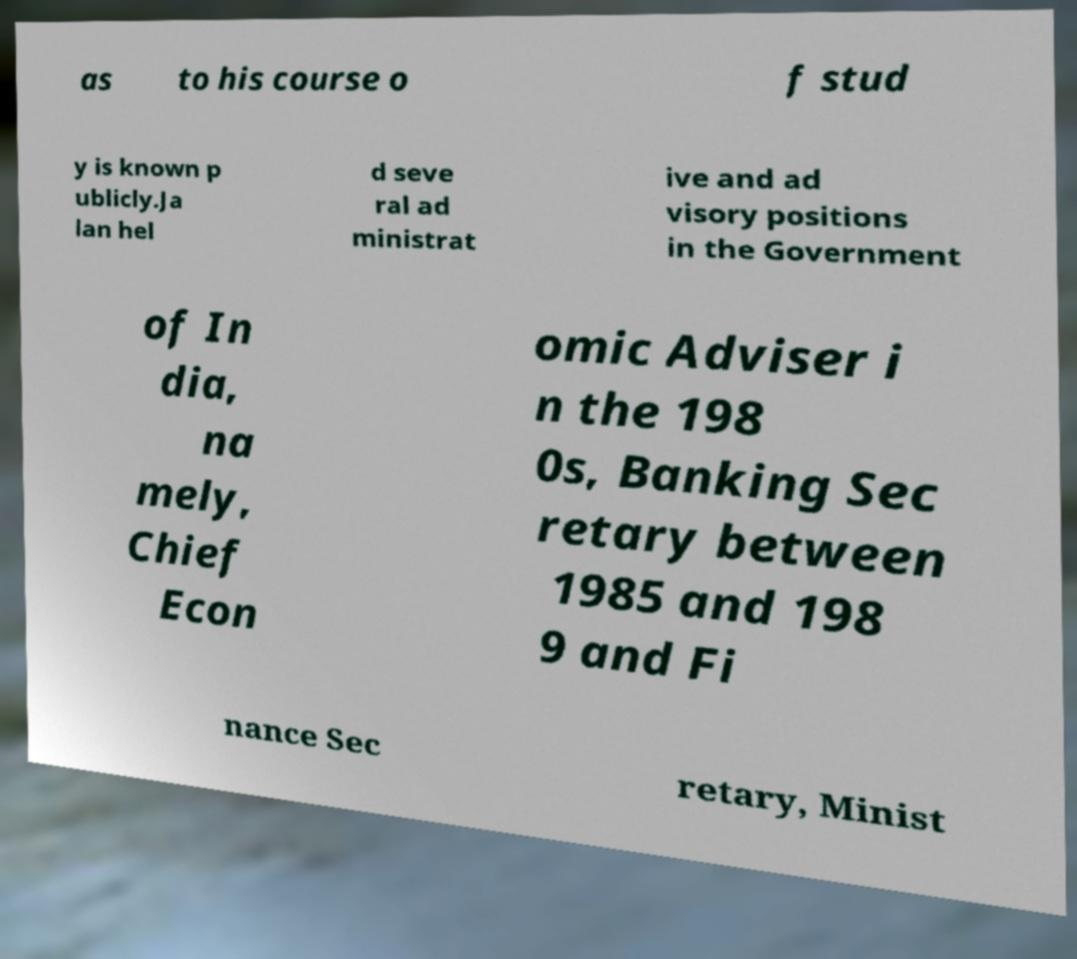I need the written content from this picture converted into text. Can you do that? as to his course o f stud y is known p ublicly.Ja lan hel d seve ral ad ministrat ive and ad visory positions in the Government of In dia, na mely, Chief Econ omic Adviser i n the 198 0s, Banking Sec retary between 1985 and 198 9 and Fi nance Sec retary, Minist 